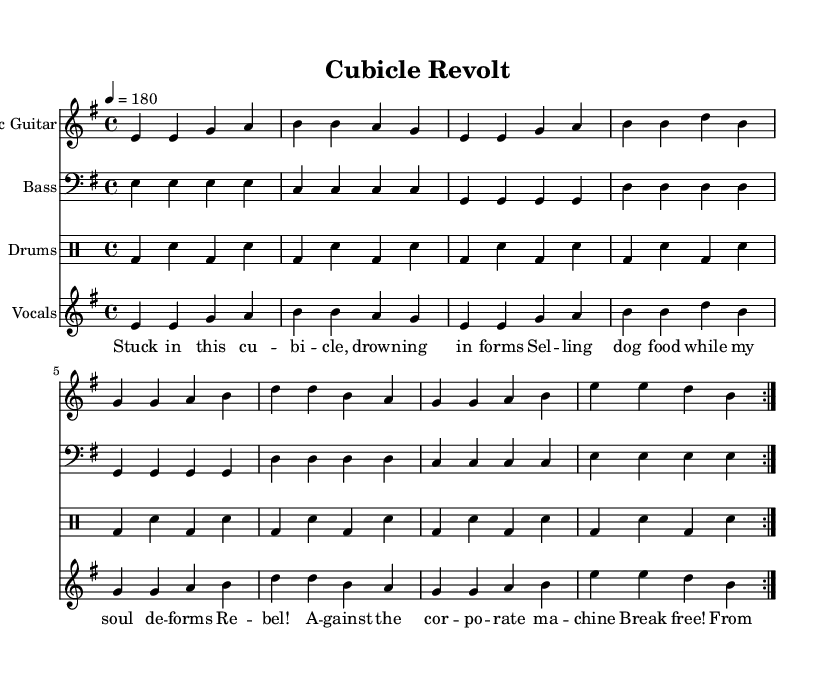What is the key signature of this music? The key signature is indicated next to the clef at the beginning of the staff. Here, it shows one sharp, which corresponds to E minor.
Answer: E minor What is the time signature of this song? The time signature appears at the beginning of the score after the key signature. It is represented as 4/4, indicating four beats in each measure, with the quarter note receiving one beat.
Answer: 4/4 What is the tempo marking of the piece? The tempo marking is located above the staff, indicating the speed at which the piece should be played. It says quarter note = 180, meaning there are 180 quarter notes in a minute.
Answer: 180 How many times is the main riff repeated? The repeat signs are indicated in the music, specifically at the beginning and end of the repeated section, which shows that it is played two times in total.
Answer: 2 What instrument plays the main melody? The main staff should indicate the instrument name next to it. Here, it indicates "Electric Guitar," denoting that the electric guitar carries the primary melodic line.
Answer: Electric Guitar What theme does the lyrics revolve around? The lyrics tell a story about frustration in a corporate setting, mentioning being stuck in a cubicle and selling pet food, which reflects a common theme of corporate rebellion.
Answer: Corporate rebellion What type of rhythm does the drum pattern have? The drum part is indicated in drummode, showing a consistent kick-snare pattern at a fast pace, typical of high-energy punk drumming, which creates an aggressive rhythm.
Answer: Fast-paced 